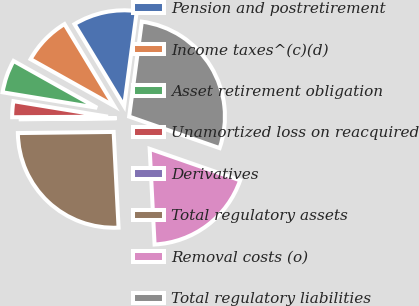Convert chart. <chart><loc_0><loc_0><loc_500><loc_500><pie_chart><fcel>Pension and postretirement<fcel>Income taxes^(c)(d)<fcel>Asset retirement obligation<fcel>Unamortized loss on reacquired<fcel>Derivatives<fcel>Total regulatory assets<fcel>Removal costs (o)<fcel>Total regulatory liabilities<nl><fcel>10.78%<fcel>8.2%<fcel>5.55%<fcel>2.68%<fcel>0.09%<fcel>25.63%<fcel>18.85%<fcel>28.22%<nl></chart> 